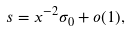Convert formula to latex. <formula><loc_0><loc_0><loc_500><loc_500>s = x ^ { - 2 } \sigma _ { 0 } + o ( 1 ) ,</formula> 